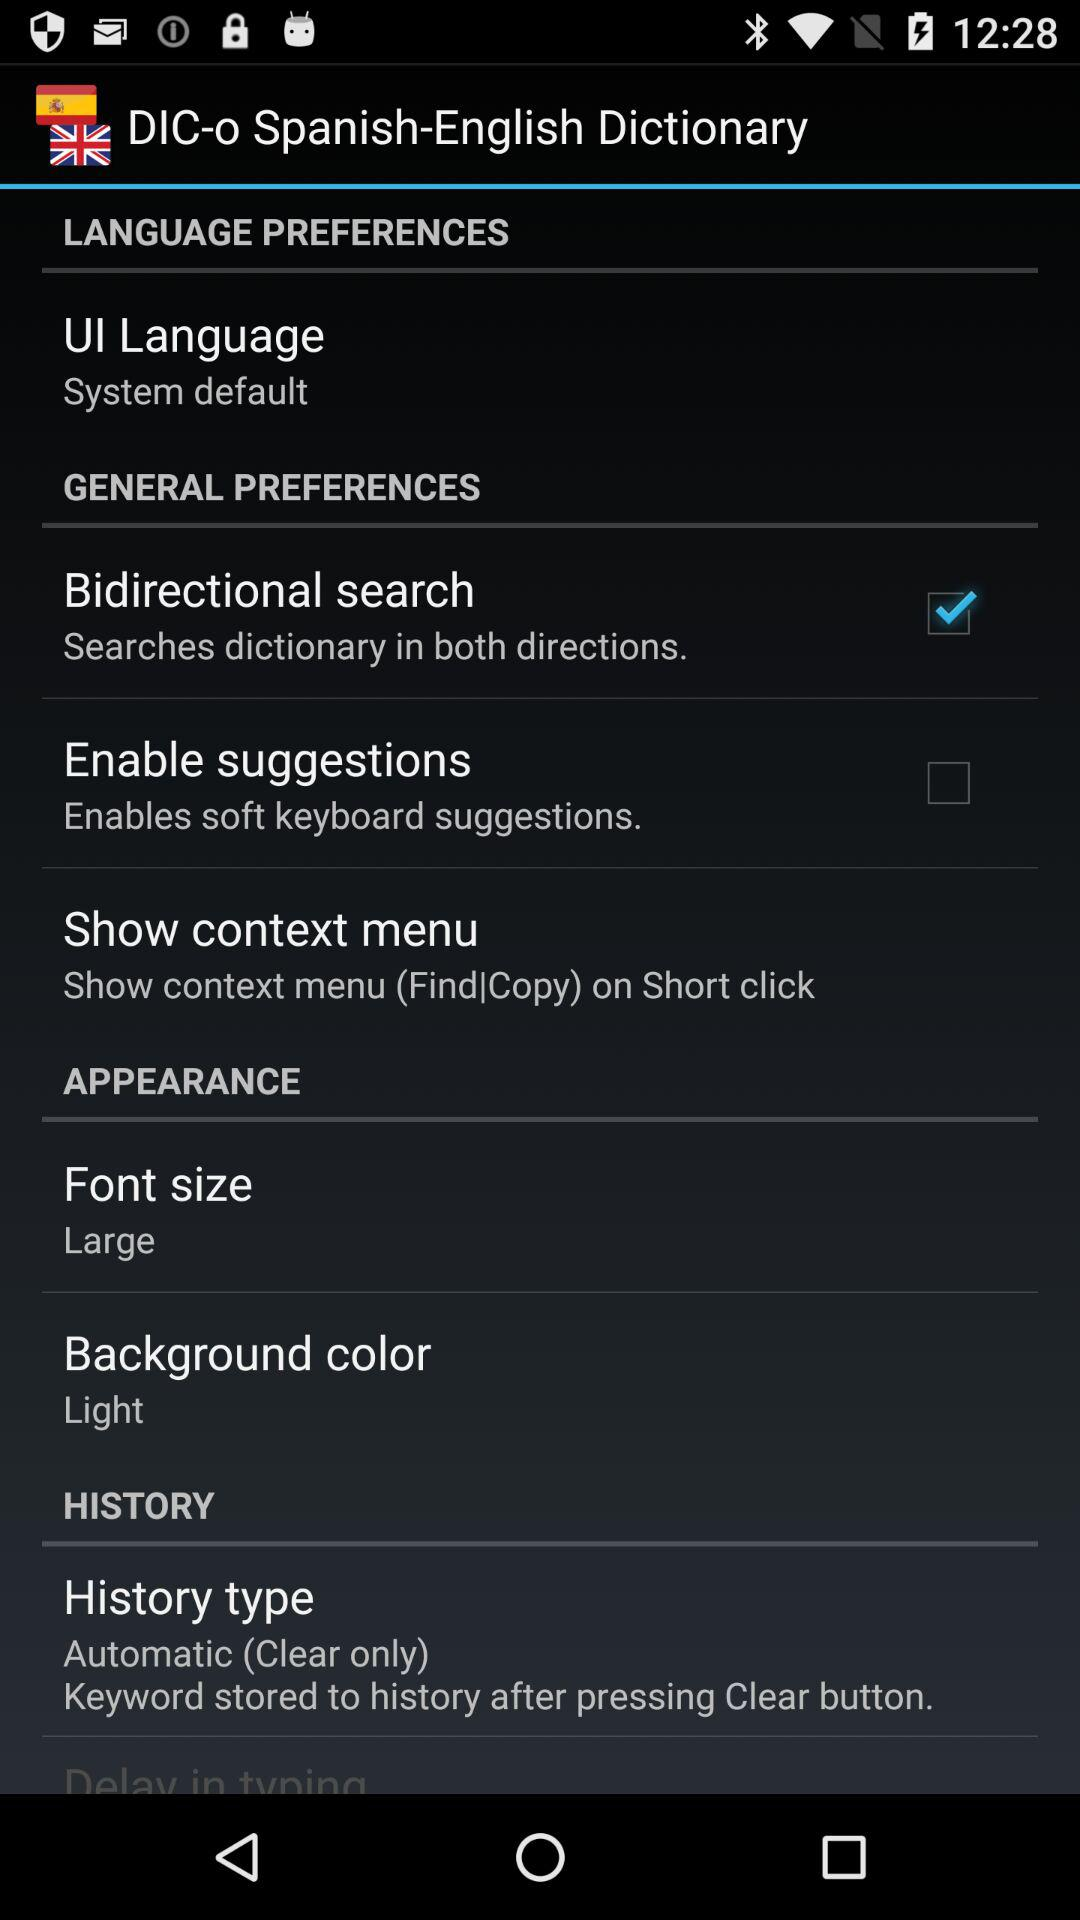Which option is marked as checked? The option that is marked as checked is "Bidirectional search". 